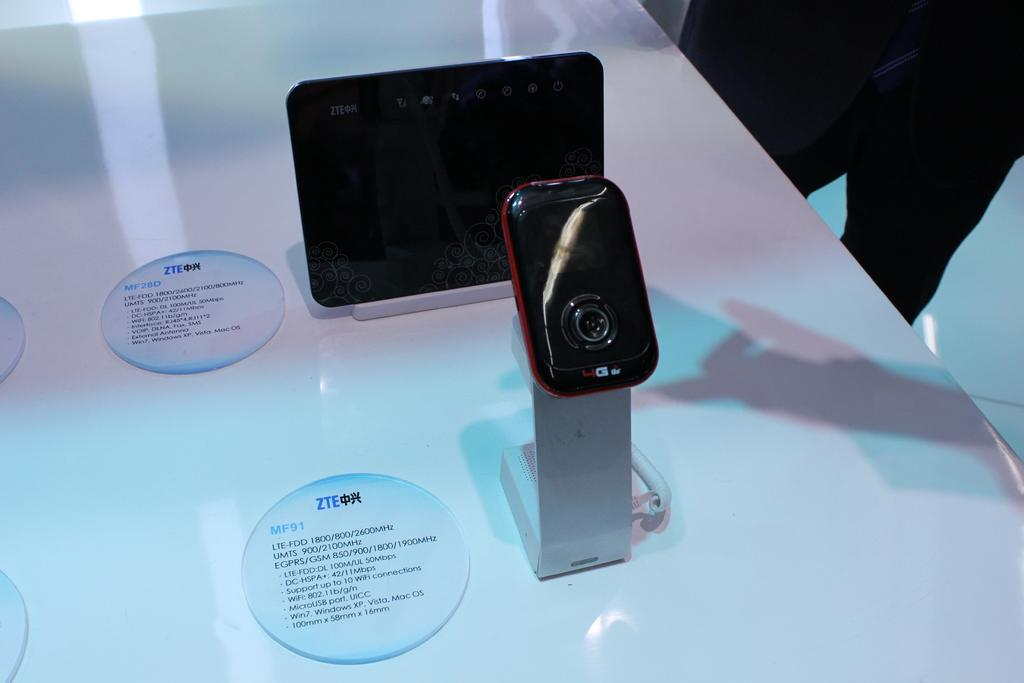Provide a one-sentence caption for the provided image. A round tag with ZTE and MF91 is on the table next to the item on display. 